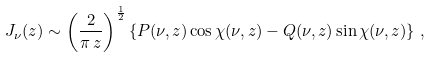Convert formula to latex. <formula><loc_0><loc_0><loc_500><loc_500>J _ { \nu } ( z ) \sim \left ( \frac { 2 } { \pi \, z } \right ) ^ { \frac { 1 } { 2 } } \left \{ P ( \nu , z ) \cos \chi ( \nu , z ) - Q ( \nu , z ) \sin \chi ( \nu , z ) \right \} \, ,</formula> 